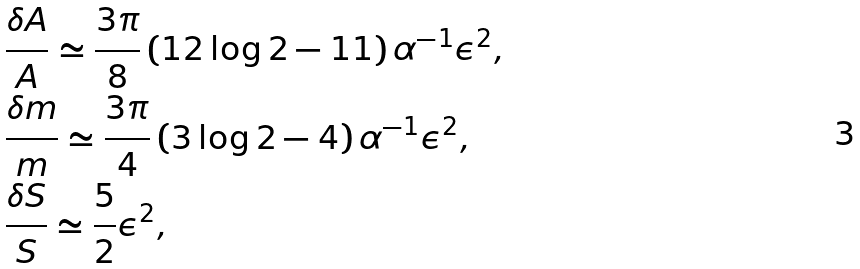<formula> <loc_0><loc_0><loc_500><loc_500>& \frac { \delta A } { A } \simeq \frac { 3 \pi } { 8 } \left ( 1 2 \log 2 - 1 1 \right ) \alpha ^ { - 1 } \epsilon ^ { 2 } , \\ & \frac { \delta m } { m } \simeq \frac { 3 \pi } { 4 } \left ( 3 \log 2 - 4 \right ) \alpha ^ { - 1 } \epsilon ^ { 2 } , \\ & \frac { \delta S } { S } \simeq \frac { 5 } { 2 } \epsilon ^ { 2 } ,</formula> 